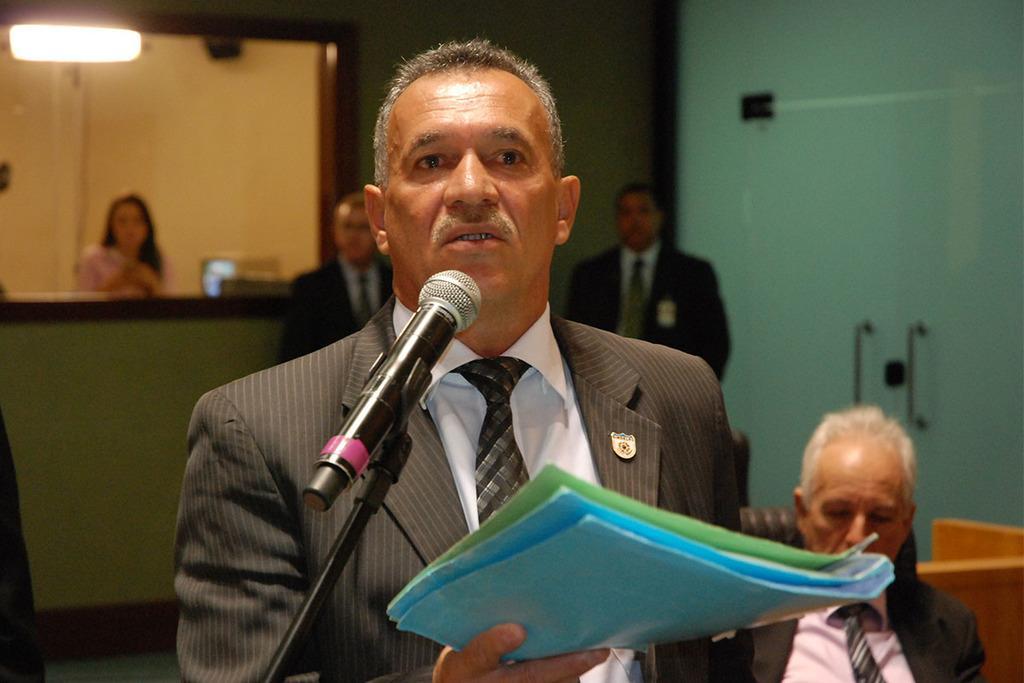Can you describe this image briefly? This picture seems to be clicked inside the room. In the foreground we can see a man wearing suit, holding some objects, standing and seems to be talking and we can see a microphone attached to the metal stand and we can see a person sitting on the chair. In the background we can see the door and some other objects and we can see the two persons wearing suits and standing and we can see the light, a person and some other objects. 